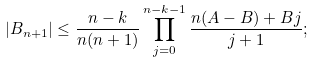Convert formula to latex. <formula><loc_0><loc_0><loc_500><loc_500>\left | B _ { n + 1 } \right | \leq \frac { n - k } { n ( n + 1 ) } \prod _ { j = 0 } ^ { n - k - 1 } \frac { n ( A - B ) + B j } { j + 1 } ;</formula> 